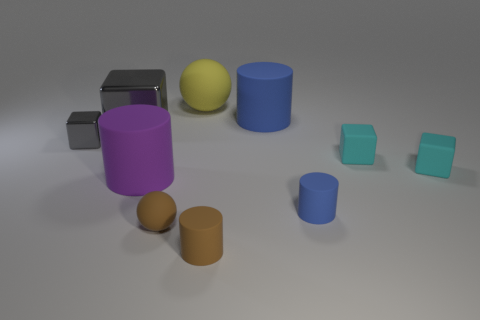Subtract 1 cubes. How many cubes are left? 3 Subtract all balls. How many objects are left? 8 Subtract 0 green cylinders. How many objects are left? 10 Subtract all big cylinders. Subtract all tiny brown matte cylinders. How many objects are left? 7 Add 5 tiny cyan things. How many tiny cyan things are left? 7 Add 1 tiny purple spheres. How many tiny purple spheres exist? 1 